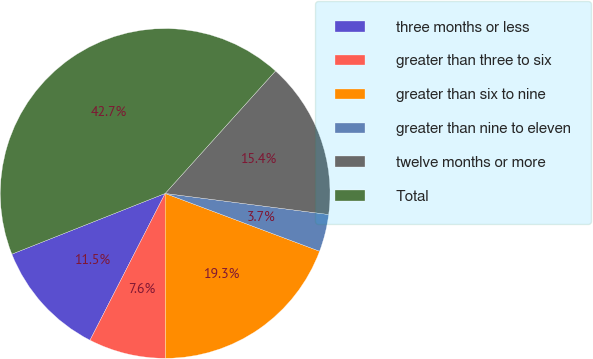Convert chart. <chart><loc_0><loc_0><loc_500><loc_500><pie_chart><fcel>three months or less<fcel>greater than three to six<fcel>greater than six to nine<fcel>greater than nine to eleven<fcel>twelve months or more<fcel>Total<nl><fcel>11.47%<fcel>7.56%<fcel>19.27%<fcel>3.66%<fcel>15.37%<fcel>42.67%<nl></chart> 